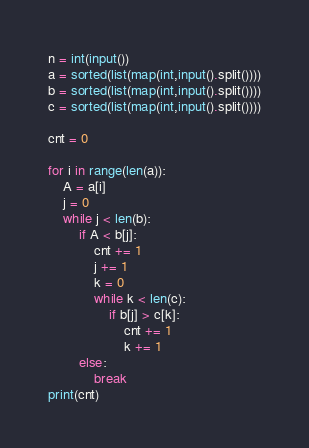<code> <loc_0><loc_0><loc_500><loc_500><_Python_>n = int(input())
a = sorted(list(map(int,input().split())))
b = sorted(list(map(int,input().split())))
c = sorted(list(map(int,input().split())))

cnt = 0

for i in range(len(a)):
    A = a[i]
    j = 0
    while j < len(b):
        if A < b[j]:
            cnt += 1
            j += 1
            k = 0
            while k < len(c):
                if b[j] > c[k]:
                    cnt += 1
                    k += 1
        else:
            break
print(cnt)</code> 